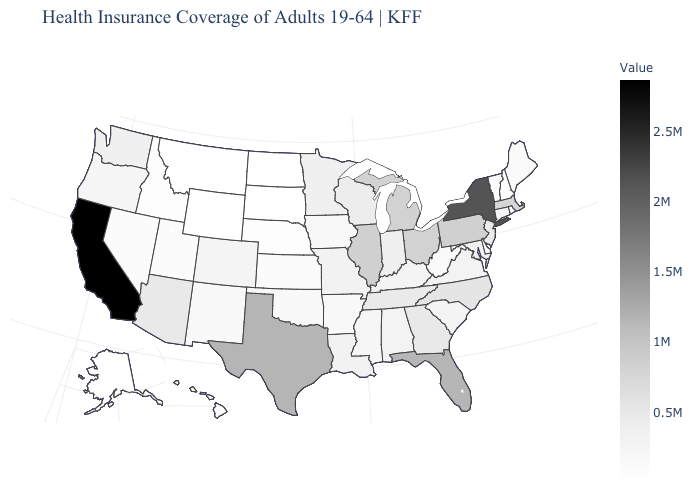Does Florida have a lower value than Hawaii?
Give a very brief answer. No. Which states have the lowest value in the USA?
Concise answer only. Wyoming. Among the states that border California , does Nevada have the highest value?
Write a very short answer. No. Among the states that border Mississippi , which have the lowest value?
Answer briefly. Arkansas. Does California have the highest value in the USA?
Quick response, please. Yes. Among the states that border Illinois , which have the lowest value?
Give a very brief answer. Iowa. Among the states that border Pennsylvania , which have the lowest value?
Give a very brief answer. Delaware. 